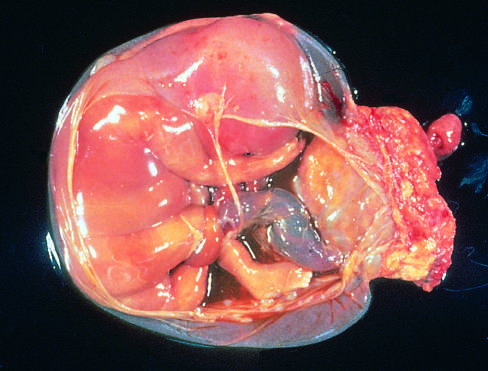does the band of amnion extend from the portion of the amniotic sac to encircle the leg of the fetus?
Answer the question using a single word or phrase. Yes 